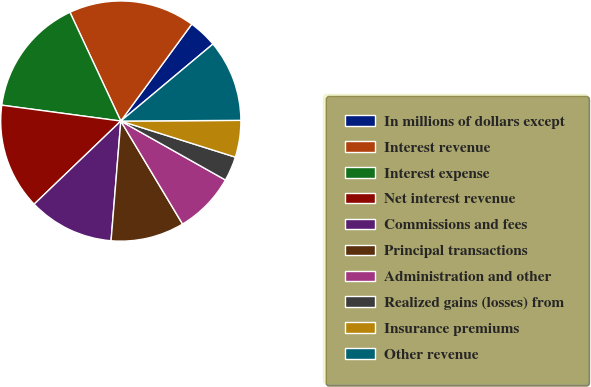Convert chart. <chart><loc_0><loc_0><loc_500><loc_500><pie_chart><fcel>In millions of dollars except<fcel>Interest revenue<fcel>Interest expense<fcel>Net interest revenue<fcel>Commissions and fees<fcel>Principal transactions<fcel>Administration and other<fcel>Realized gains (losses) from<fcel>Insurance premiums<fcel>Other revenue<nl><fcel>3.86%<fcel>17.02%<fcel>15.93%<fcel>14.28%<fcel>11.54%<fcel>9.89%<fcel>8.24%<fcel>3.31%<fcel>4.95%<fcel>10.99%<nl></chart> 